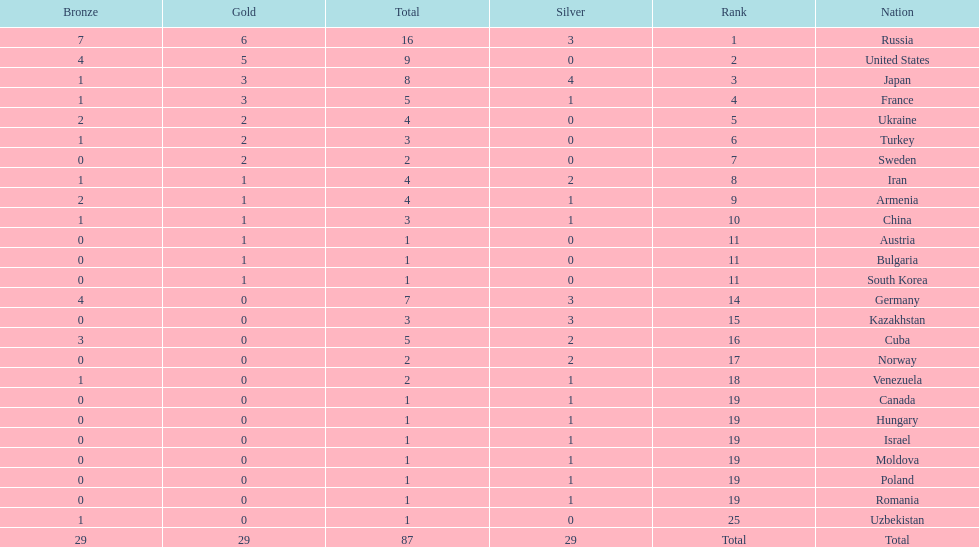How many combined gold medals did japan and france win? 6. 